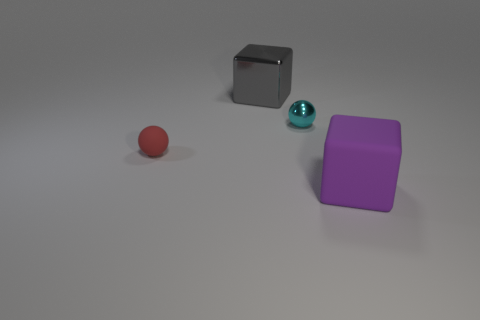Add 1 cyan things. How many objects exist? 5 Subtract 0 blue cubes. How many objects are left? 4 Subtract all large metallic objects. Subtract all big gray metal things. How many objects are left? 2 Add 4 cyan metallic spheres. How many cyan metallic spheres are left? 5 Add 4 large blue rubber cubes. How many large blue rubber cubes exist? 4 